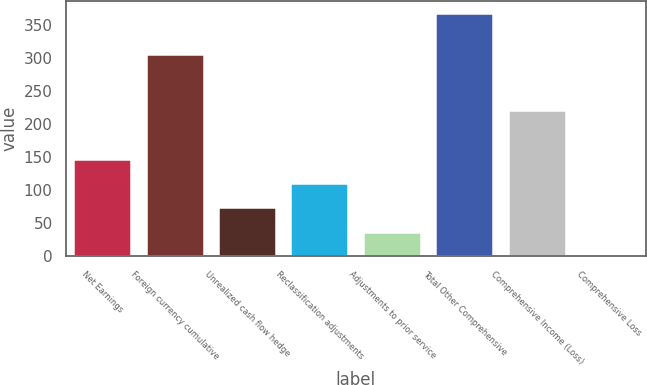Convert chart. <chart><loc_0><loc_0><loc_500><loc_500><bar_chart><fcel>Net Earnings<fcel>Foreign currency cumulative<fcel>Unrealized cash flow hedge<fcel>Reclassification adjustments<fcel>Adjustments to prior service<fcel>Total Other Comprehensive<fcel>Comprehensive Income (Loss)<fcel>Comprehensive Loss<nl><fcel>147.02<fcel>305.2<fcel>73.66<fcel>110.34<fcel>36.98<fcel>367.1<fcel>220.6<fcel>0.3<nl></chart> 